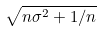<formula> <loc_0><loc_0><loc_500><loc_500>\sqrt { n \sigma ^ { 2 } + 1 / n }</formula> 